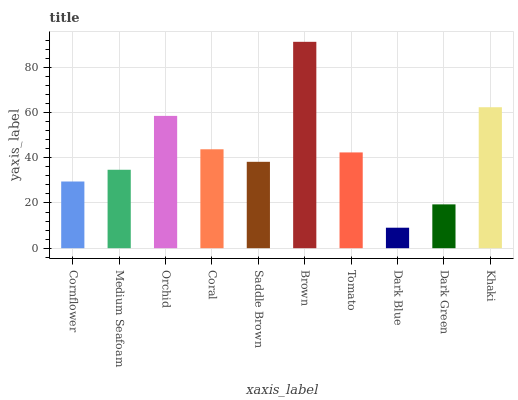Is Medium Seafoam the minimum?
Answer yes or no. No. Is Medium Seafoam the maximum?
Answer yes or no. No. Is Medium Seafoam greater than Cornflower?
Answer yes or no. Yes. Is Cornflower less than Medium Seafoam?
Answer yes or no. Yes. Is Cornflower greater than Medium Seafoam?
Answer yes or no. No. Is Medium Seafoam less than Cornflower?
Answer yes or no. No. Is Tomato the high median?
Answer yes or no. Yes. Is Saddle Brown the low median?
Answer yes or no. Yes. Is Khaki the high median?
Answer yes or no. No. Is Dark Green the low median?
Answer yes or no. No. 